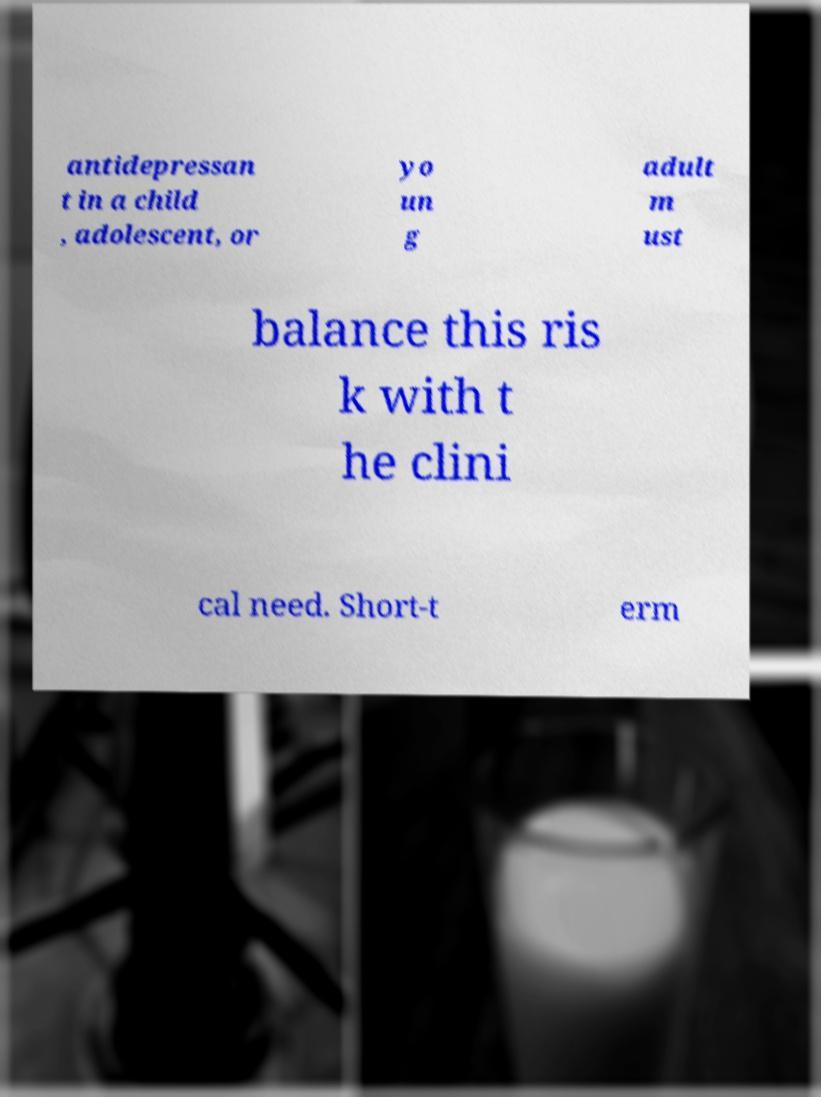Please identify and transcribe the text found in this image. antidepressan t in a child , adolescent, or yo un g adult m ust balance this ris k with t he clini cal need. Short-t erm 